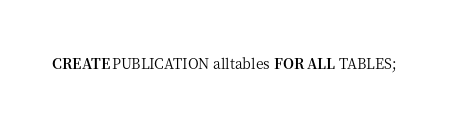<code> <loc_0><loc_0><loc_500><loc_500><_SQL_>CREATE PUBLICATION alltables FOR ALL TABLES;
</code> 